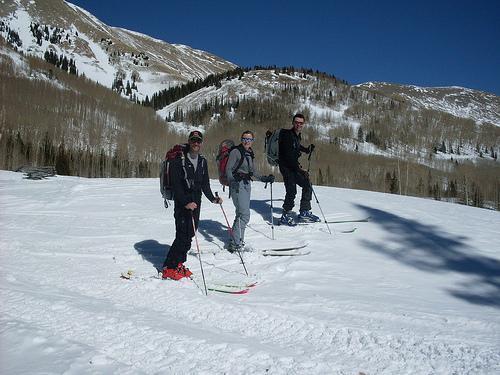How many men are in this picture?
Give a very brief answer. 3. How many of the men are dressed in black?
Give a very brief answer. 2. How many men are wearing hats?
Give a very brief answer. 1. 